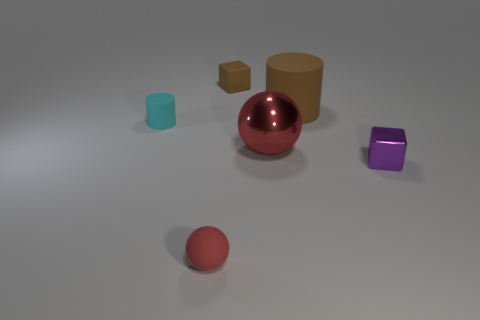Is there any other thing that is the same color as the small rubber sphere?
Offer a very short reply. Yes. Is the cyan matte object the same shape as the small brown rubber object?
Your answer should be very brief. No. There is a cube that is in front of the cylinder on the right side of the object that is in front of the purple metal thing; what size is it?
Offer a very short reply. Small. What number of other things are the same material as the small red sphere?
Provide a succinct answer. 3. The small rubber thing that is to the left of the rubber sphere is what color?
Ensure brevity in your answer.  Cyan. There is a brown object on the right side of the red sphere to the right of the red object in front of the small shiny cube; what is it made of?
Your response must be concise. Rubber. Are there any red things of the same shape as the cyan thing?
Ensure brevity in your answer.  No. What is the shape of the brown thing that is the same size as the cyan matte thing?
Your answer should be very brief. Cube. How many rubber objects are both in front of the purple cube and behind the small cyan thing?
Offer a terse response. 0. Are there fewer small brown objects that are behind the brown rubber block than yellow matte balls?
Your response must be concise. No. 